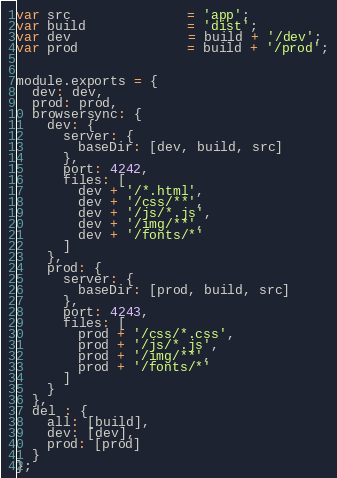Convert code to text. <code><loc_0><loc_0><loc_500><loc_500><_JavaScript_>var src               = 'app';
var build             = 'dist';
var dev               = build + '/dev';
var prod              = build + '/prod';


module.exports = {
  dev: dev,
  prod: prod,
  browsersync: {
    dev: {
      server: {
        baseDir: [dev, build, src]
      },
      port: 4242,
      files: [
        dev + '/*.html',
        dev + '/css/**',
        dev + '/js/*.js',
        dev + '/img/**',
        dev + '/fonts/*'
      ]
    },
    prod: {
      server: {
        baseDir: [prod, build, src]
      },
      port: 4243,
      files: [
        prod + '/css/*.css',
        prod + '/js/*.js',
        prod + '/img/**',
        prod + '/fonts/*'
      ]
    }
  },
  del : {
    all: [build],
    dev: [dev],
    prod: [prod]
  }
};
</code> 